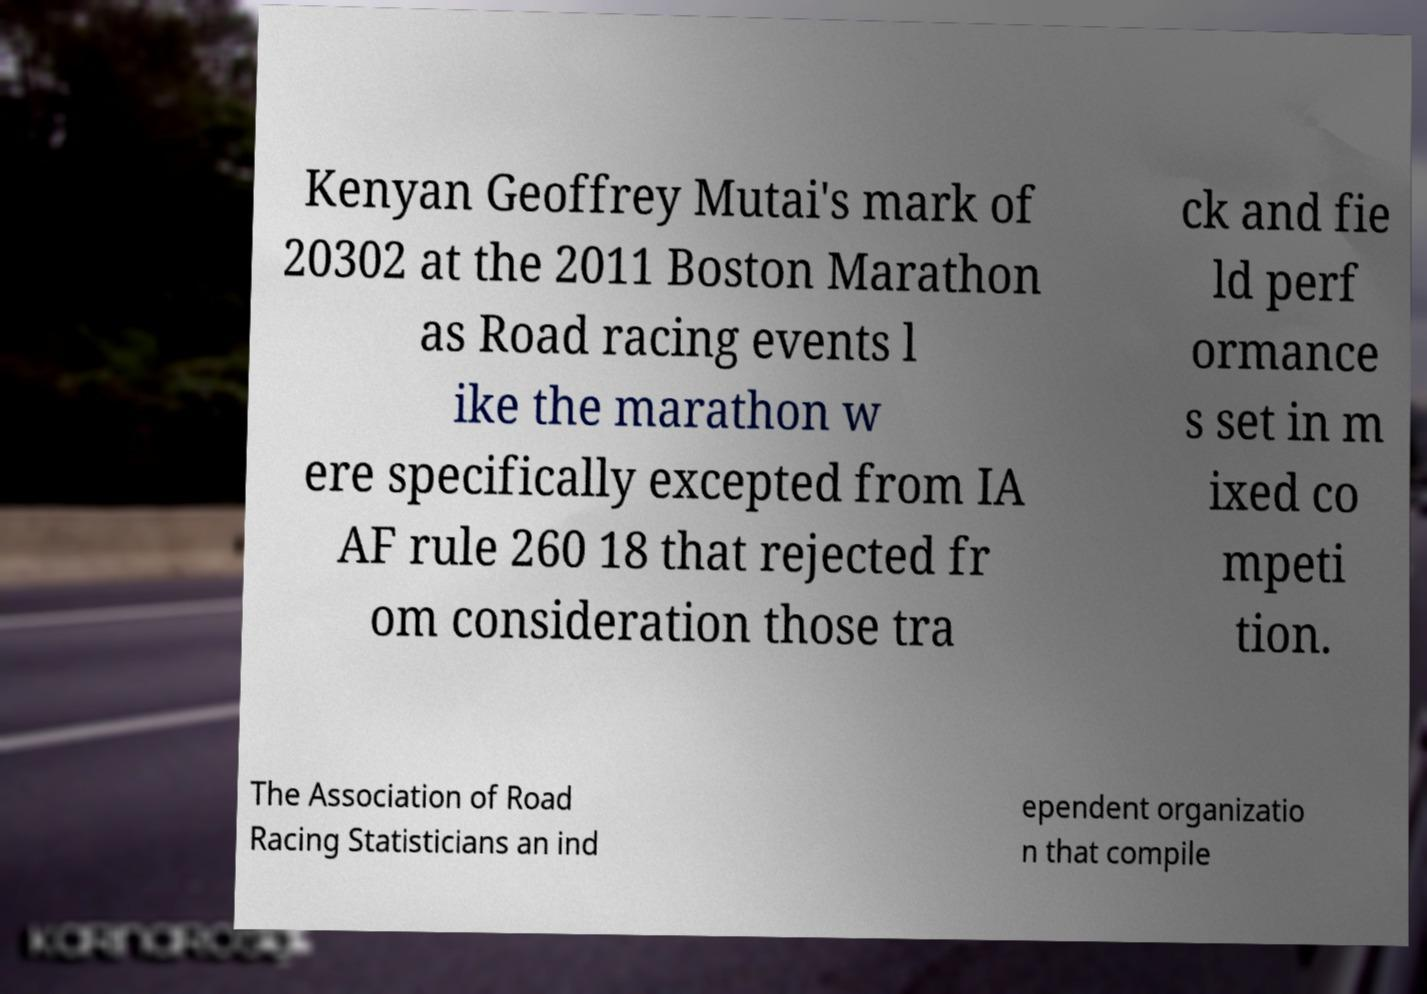Please read and relay the text visible in this image. What does it say? Kenyan Geoffrey Mutai's mark of 20302 at the 2011 Boston Marathon as Road racing events l ike the marathon w ere specifically excepted from IA AF rule 260 18 that rejected fr om consideration those tra ck and fie ld perf ormance s set in m ixed co mpeti tion. The Association of Road Racing Statisticians an ind ependent organizatio n that compile 